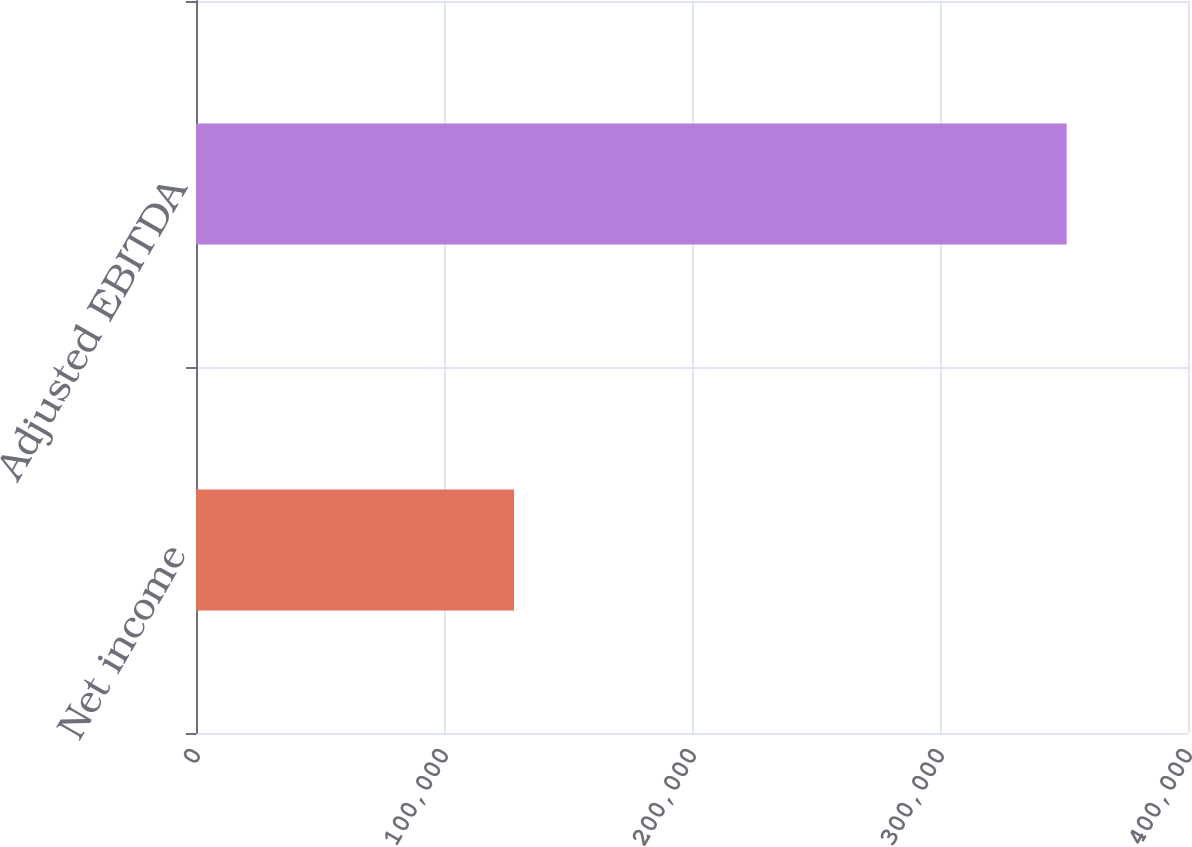Convert chart to OTSL. <chart><loc_0><loc_0><loc_500><loc_500><bar_chart><fcel>Net income<fcel>Adjusted EBITDA<nl><fcel>128237<fcel>351071<nl></chart> 